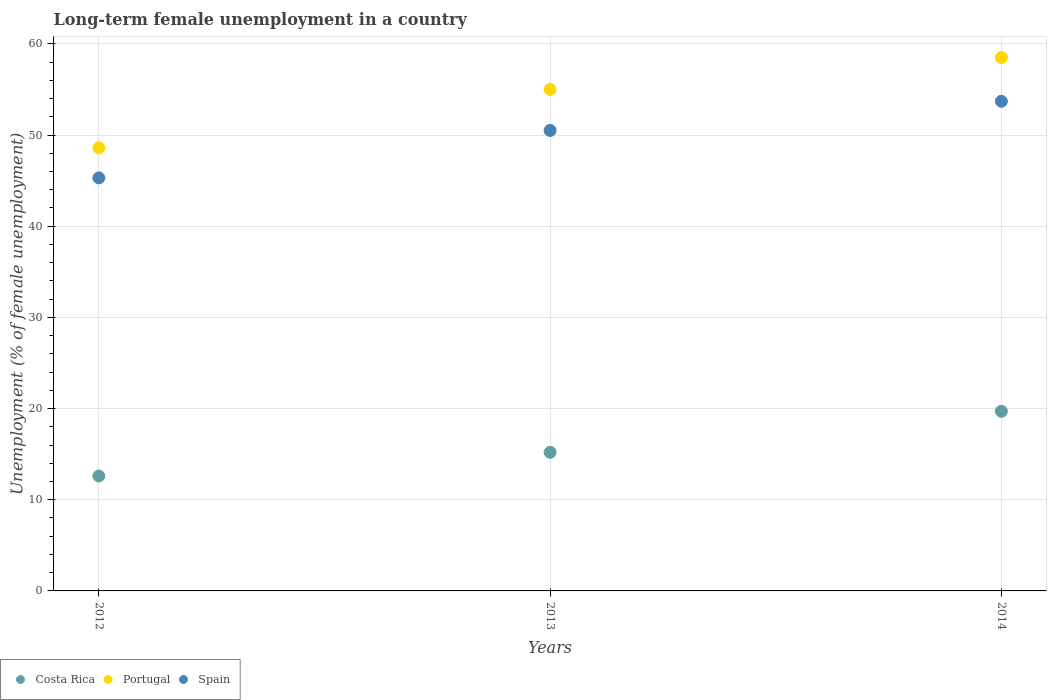How many different coloured dotlines are there?
Provide a succinct answer. 3. Is the number of dotlines equal to the number of legend labels?
Your answer should be very brief. Yes. What is the percentage of long-term unemployed female population in Spain in 2013?
Keep it short and to the point. 50.5. Across all years, what is the maximum percentage of long-term unemployed female population in Costa Rica?
Provide a succinct answer. 19.7. Across all years, what is the minimum percentage of long-term unemployed female population in Costa Rica?
Offer a very short reply. 12.6. What is the total percentage of long-term unemployed female population in Portugal in the graph?
Keep it short and to the point. 162.1. What is the difference between the percentage of long-term unemployed female population in Costa Rica in 2012 and that in 2014?
Your answer should be very brief. -7.1. What is the difference between the percentage of long-term unemployed female population in Costa Rica in 2013 and the percentage of long-term unemployed female population in Portugal in 2012?
Provide a short and direct response. -33.4. What is the average percentage of long-term unemployed female population in Costa Rica per year?
Ensure brevity in your answer.  15.83. In the year 2013, what is the difference between the percentage of long-term unemployed female population in Spain and percentage of long-term unemployed female population in Costa Rica?
Offer a terse response. 35.3. What is the ratio of the percentage of long-term unemployed female population in Spain in 2013 to that in 2014?
Ensure brevity in your answer.  0.94. Is the percentage of long-term unemployed female population in Spain in 2012 less than that in 2013?
Provide a short and direct response. Yes. What is the difference between the highest and the second highest percentage of long-term unemployed female population in Costa Rica?
Provide a succinct answer. 4.5. What is the difference between the highest and the lowest percentage of long-term unemployed female population in Portugal?
Give a very brief answer. 9.9. Is it the case that in every year, the sum of the percentage of long-term unemployed female population in Portugal and percentage of long-term unemployed female population in Costa Rica  is greater than the percentage of long-term unemployed female population in Spain?
Make the answer very short. Yes. Does the percentage of long-term unemployed female population in Spain monotonically increase over the years?
Your answer should be compact. Yes. How many years are there in the graph?
Your answer should be very brief. 3. What is the difference between two consecutive major ticks on the Y-axis?
Keep it short and to the point. 10. Are the values on the major ticks of Y-axis written in scientific E-notation?
Make the answer very short. No. Does the graph contain any zero values?
Your answer should be compact. No. How are the legend labels stacked?
Offer a terse response. Horizontal. What is the title of the graph?
Make the answer very short. Long-term female unemployment in a country. What is the label or title of the Y-axis?
Give a very brief answer. Unemployment (% of female unemployment). What is the Unemployment (% of female unemployment) in Costa Rica in 2012?
Provide a short and direct response. 12.6. What is the Unemployment (% of female unemployment) in Portugal in 2012?
Provide a succinct answer. 48.6. What is the Unemployment (% of female unemployment) in Spain in 2012?
Ensure brevity in your answer.  45.3. What is the Unemployment (% of female unemployment) in Costa Rica in 2013?
Provide a succinct answer. 15.2. What is the Unemployment (% of female unemployment) in Spain in 2013?
Offer a very short reply. 50.5. What is the Unemployment (% of female unemployment) in Costa Rica in 2014?
Your answer should be very brief. 19.7. What is the Unemployment (% of female unemployment) of Portugal in 2014?
Offer a very short reply. 58.5. What is the Unemployment (% of female unemployment) of Spain in 2014?
Keep it short and to the point. 53.7. Across all years, what is the maximum Unemployment (% of female unemployment) in Costa Rica?
Keep it short and to the point. 19.7. Across all years, what is the maximum Unemployment (% of female unemployment) of Portugal?
Make the answer very short. 58.5. Across all years, what is the maximum Unemployment (% of female unemployment) of Spain?
Make the answer very short. 53.7. Across all years, what is the minimum Unemployment (% of female unemployment) in Costa Rica?
Give a very brief answer. 12.6. Across all years, what is the minimum Unemployment (% of female unemployment) of Portugal?
Make the answer very short. 48.6. Across all years, what is the minimum Unemployment (% of female unemployment) in Spain?
Offer a terse response. 45.3. What is the total Unemployment (% of female unemployment) in Costa Rica in the graph?
Your answer should be very brief. 47.5. What is the total Unemployment (% of female unemployment) of Portugal in the graph?
Ensure brevity in your answer.  162.1. What is the total Unemployment (% of female unemployment) of Spain in the graph?
Your response must be concise. 149.5. What is the difference between the Unemployment (% of female unemployment) of Portugal in 2012 and that in 2013?
Your answer should be compact. -6.4. What is the difference between the Unemployment (% of female unemployment) of Spain in 2012 and that in 2013?
Ensure brevity in your answer.  -5.2. What is the difference between the Unemployment (% of female unemployment) of Portugal in 2012 and that in 2014?
Offer a terse response. -9.9. What is the difference between the Unemployment (% of female unemployment) in Costa Rica in 2013 and that in 2014?
Give a very brief answer. -4.5. What is the difference between the Unemployment (% of female unemployment) of Portugal in 2013 and that in 2014?
Give a very brief answer. -3.5. What is the difference between the Unemployment (% of female unemployment) of Spain in 2013 and that in 2014?
Your answer should be compact. -3.2. What is the difference between the Unemployment (% of female unemployment) in Costa Rica in 2012 and the Unemployment (% of female unemployment) in Portugal in 2013?
Your response must be concise. -42.4. What is the difference between the Unemployment (% of female unemployment) of Costa Rica in 2012 and the Unemployment (% of female unemployment) of Spain in 2013?
Your answer should be very brief. -37.9. What is the difference between the Unemployment (% of female unemployment) in Costa Rica in 2012 and the Unemployment (% of female unemployment) in Portugal in 2014?
Make the answer very short. -45.9. What is the difference between the Unemployment (% of female unemployment) in Costa Rica in 2012 and the Unemployment (% of female unemployment) in Spain in 2014?
Offer a very short reply. -41.1. What is the difference between the Unemployment (% of female unemployment) in Costa Rica in 2013 and the Unemployment (% of female unemployment) in Portugal in 2014?
Provide a short and direct response. -43.3. What is the difference between the Unemployment (% of female unemployment) of Costa Rica in 2013 and the Unemployment (% of female unemployment) of Spain in 2014?
Your answer should be compact. -38.5. What is the difference between the Unemployment (% of female unemployment) of Portugal in 2013 and the Unemployment (% of female unemployment) of Spain in 2014?
Provide a short and direct response. 1.3. What is the average Unemployment (% of female unemployment) in Costa Rica per year?
Provide a succinct answer. 15.83. What is the average Unemployment (% of female unemployment) in Portugal per year?
Provide a short and direct response. 54.03. What is the average Unemployment (% of female unemployment) in Spain per year?
Provide a succinct answer. 49.83. In the year 2012, what is the difference between the Unemployment (% of female unemployment) in Costa Rica and Unemployment (% of female unemployment) in Portugal?
Offer a terse response. -36. In the year 2012, what is the difference between the Unemployment (% of female unemployment) in Costa Rica and Unemployment (% of female unemployment) in Spain?
Provide a short and direct response. -32.7. In the year 2012, what is the difference between the Unemployment (% of female unemployment) in Portugal and Unemployment (% of female unemployment) in Spain?
Your answer should be very brief. 3.3. In the year 2013, what is the difference between the Unemployment (% of female unemployment) in Costa Rica and Unemployment (% of female unemployment) in Portugal?
Offer a terse response. -39.8. In the year 2013, what is the difference between the Unemployment (% of female unemployment) of Costa Rica and Unemployment (% of female unemployment) of Spain?
Provide a succinct answer. -35.3. In the year 2014, what is the difference between the Unemployment (% of female unemployment) in Costa Rica and Unemployment (% of female unemployment) in Portugal?
Give a very brief answer. -38.8. In the year 2014, what is the difference between the Unemployment (% of female unemployment) in Costa Rica and Unemployment (% of female unemployment) in Spain?
Provide a short and direct response. -34. In the year 2014, what is the difference between the Unemployment (% of female unemployment) of Portugal and Unemployment (% of female unemployment) of Spain?
Make the answer very short. 4.8. What is the ratio of the Unemployment (% of female unemployment) in Costa Rica in 2012 to that in 2013?
Provide a short and direct response. 0.83. What is the ratio of the Unemployment (% of female unemployment) of Portugal in 2012 to that in 2013?
Your response must be concise. 0.88. What is the ratio of the Unemployment (% of female unemployment) of Spain in 2012 to that in 2013?
Make the answer very short. 0.9. What is the ratio of the Unemployment (% of female unemployment) of Costa Rica in 2012 to that in 2014?
Give a very brief answer. 0.64. What is the ratio of the Unemployment (% of female unemployment) in Portugal in 2012 to that in 2014?
Your answer should be compact. 0.83. What is the ratio of the Unemployment (% of female unemployment) in Spain in 2012 to that in 2014?
Make the answer very short. 0.84. What is the ratio of the Unemployment (% of female unemployment) of Costa Rica in 2013 to that in 2014?
Ensure brevity in your answer.  0.77. What is the ratio of the Unemployment (% of female unemployment) of Portugal in 2013 to that in 2014?
Your answer should be very brief. 0.94. What is the ratio of the Unemployment (% of female unemployment) in Spain in 2013 to that in 2014?
Provide a short and direct response. 0.94. What is the difference between the highest and the second highest Unemployment (% of female unemployment) of Costa Rica?
Your answer should be very brief. 4.5. What is the difference between the highest and the second highest Unemployment (% of female unemployment) in Portugal?
Offer a very short reply. 3.5. What is the difference between the highest and the lowest Unemployment (% of female unemployment) of Spain?
Provide a succinct answer. 8.4. 